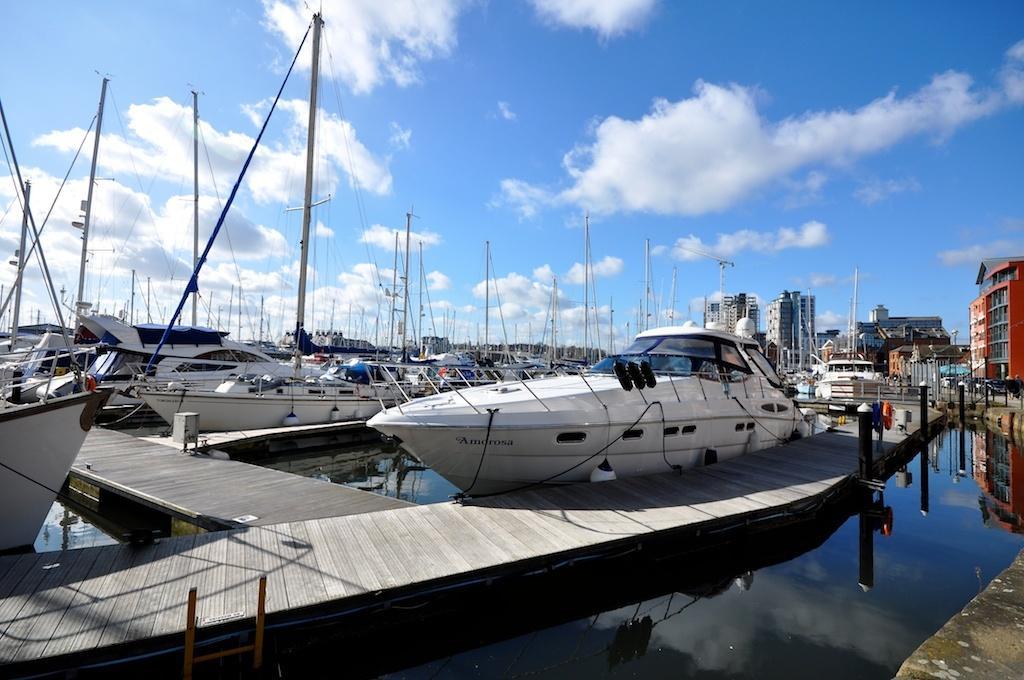Describe this image in one or two sentences. In this image I can see boats on the water. There are buildings, iron poles and in the background there is sky. 